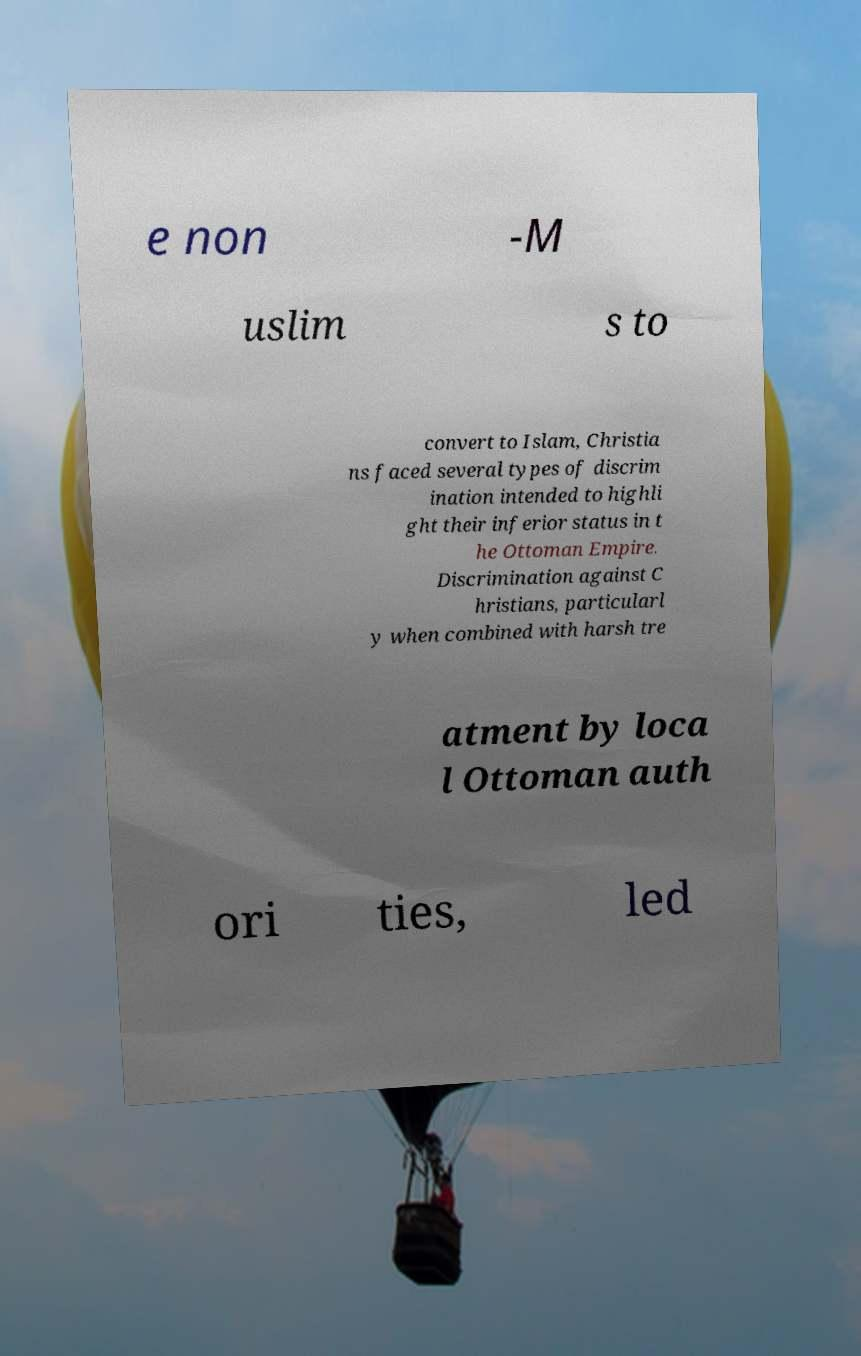For documentation purposes, I need the text within this image transcribed. Could you provide that? e non -M uslim s to convert to Islam, Christia ns faced several types of discrim ination intended to highli ght their inferior status in t he Ottoman Empire. Discrimination against C hristians, particularl y when combined with harsh tre atment by loca l Ottoman auth ori ties, led 